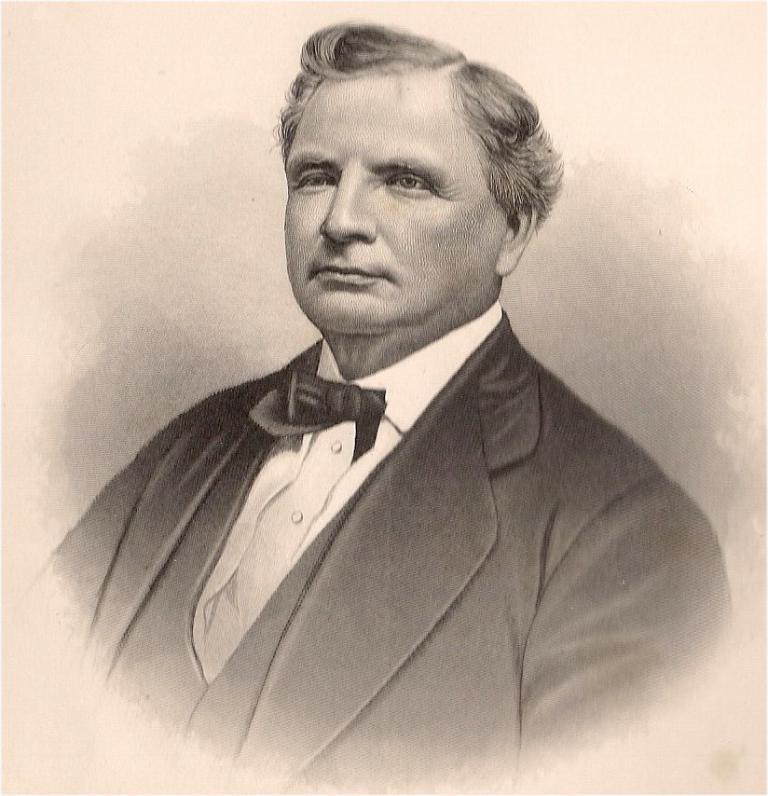Could you give a brief overview of what you see in this image? In this image I can see a drawing of a person who is wearing suit. 